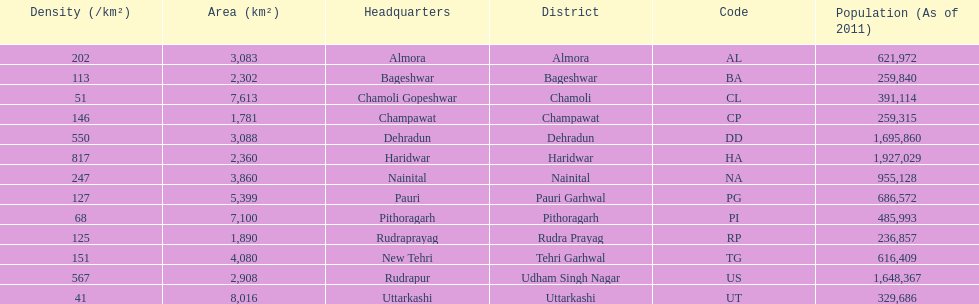What is the next most populous district after haridwar? Dehradun. 